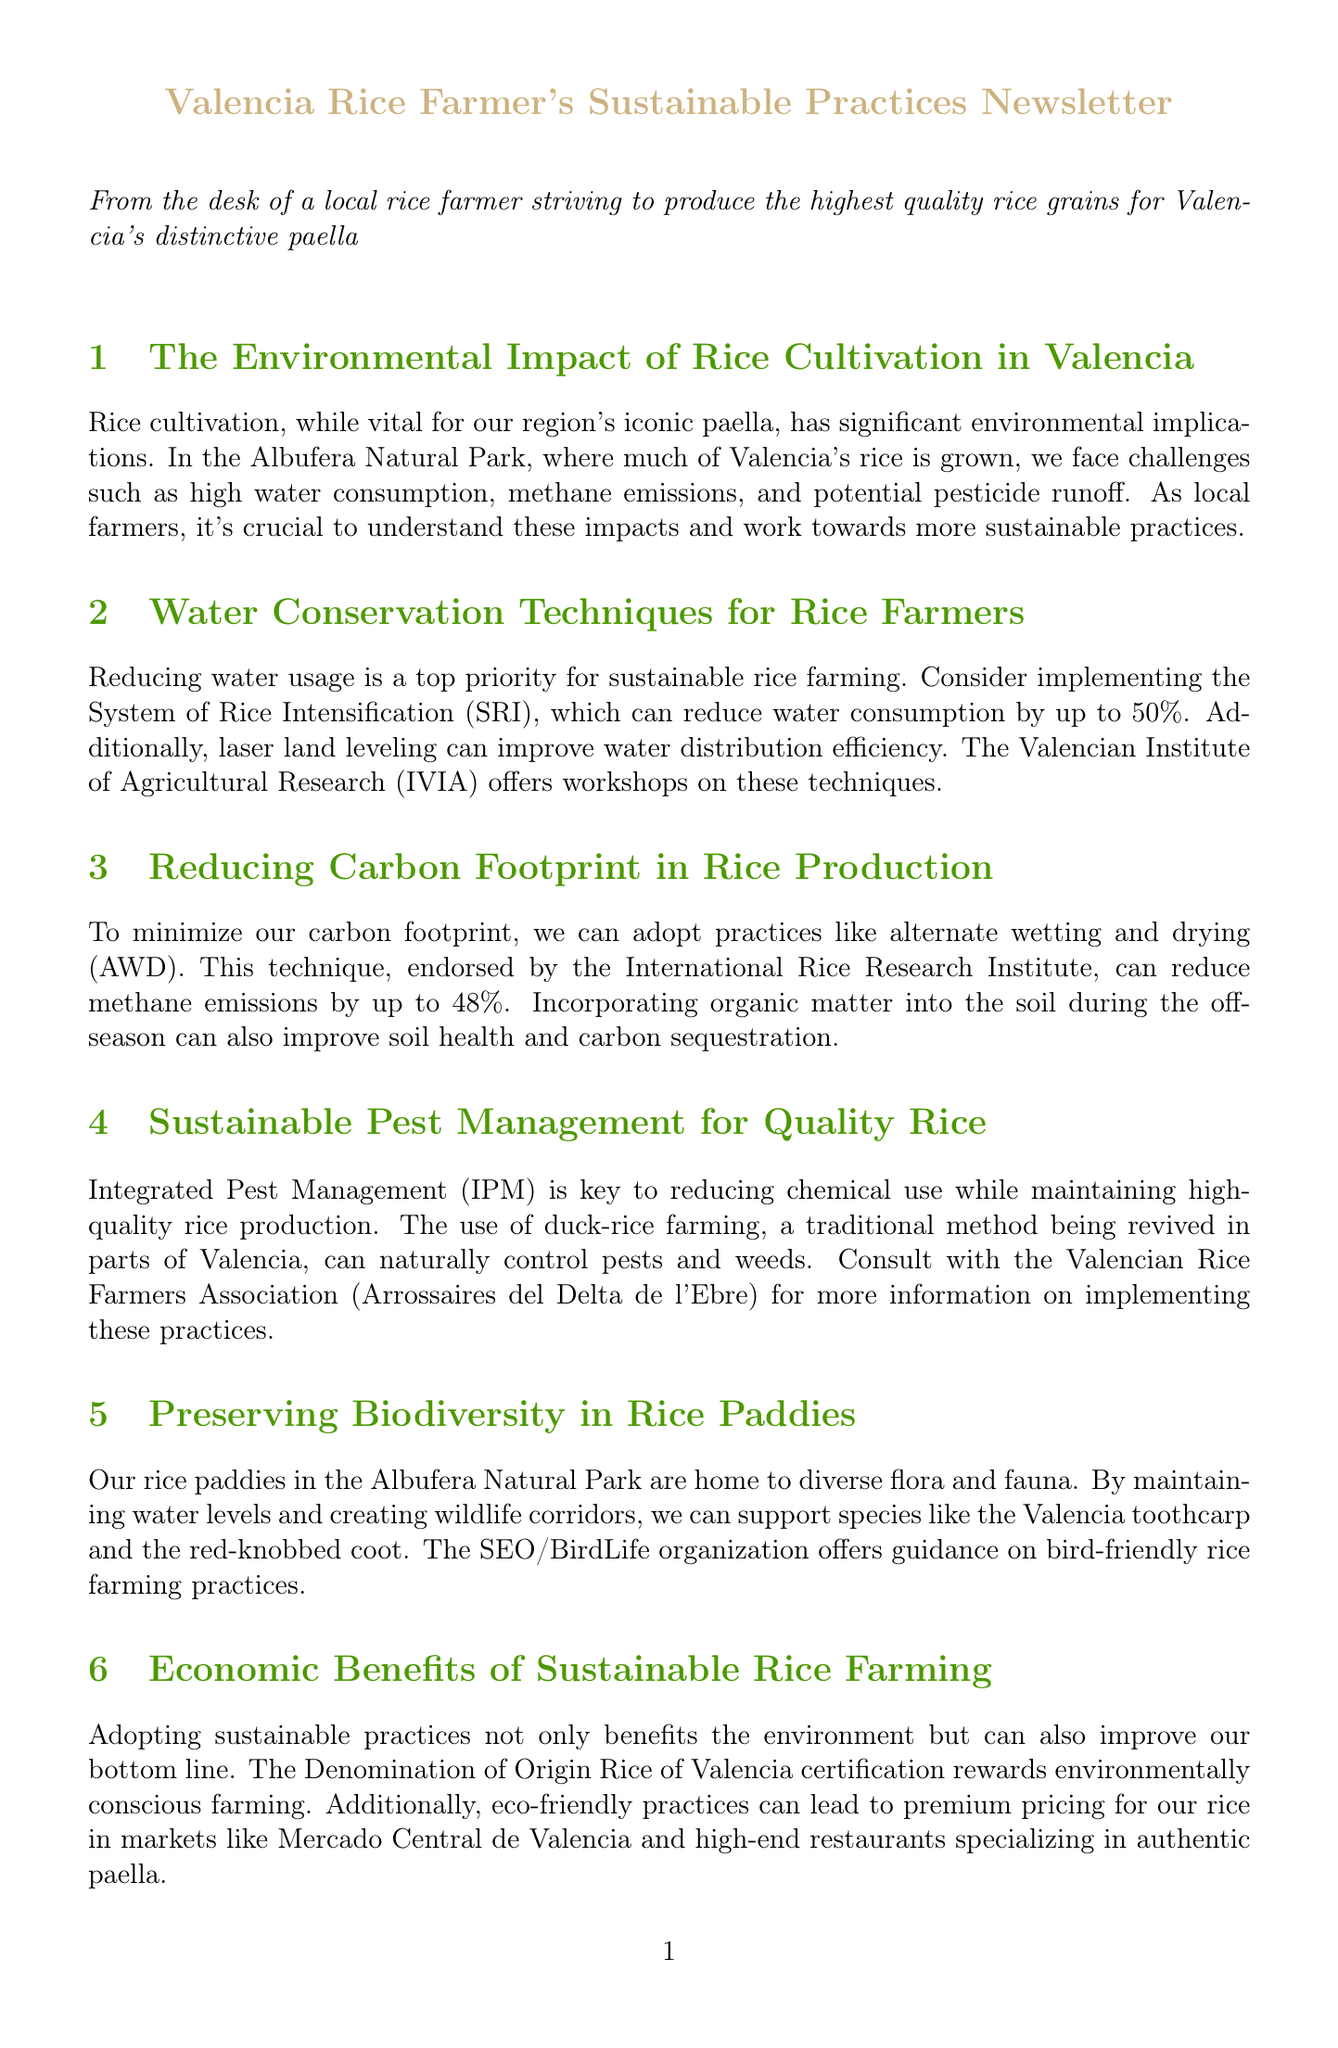What is the primary environmental challenge faced in the Albufera Natural Park? The primary environmental challenge refers to the significant implications of rice cultivation, specifically high water consumption and methane emissions.
Answer: High water consumption What technique can reduce water consumption by up to 50%? This technique is mentioned in the context of sustainable water use for rice farming, specifically the System of Rice Intensification.
Answer: System of Rice Intensification By how much can alternate wetting and drying reduce methane emissions? The document states that alternate wetting and drying can reduce methane emissions, providing a specific percentage reduction.
Answer: Up to 48% What organization offers workshops on water conservation techniques? The document lists an organization that provides resources to local farmers about sustainable practices, specifically workshops on water conservation.
Answer: Valencian Institute of Agricultural Research What traditional method helps control pests in rice farming? This method is highlighted in the section on sustainable pest management, promoting natural pest control through farming practices.
Answer: Duck-rice farming Which certification rewards environmentally conscious farming? The newsletter mentions a specific certification that recognizes sustainable practices within the rice farming community.
Answer: Denomination of Origin Rice of Valencia What is one economic benefit of adopting sustainable practices? The document discusses potential financial advantages linked to eco-friendly farming methods that can affect pricing in markets.
Answer: Premium pricing Which species can be supported by maintaining water levels in rice paddies? The document refers to a specific species that benefits from the biodiversity efforts within the rice paddies in the Albufera Natural Park.
Answer: Valencia toothcarp What practice can improve soil health during the off-season? The document mentions a farming practice that can enhance the condition of soil when rice is not being cultivated.
Answer: Incorporating organic matter 